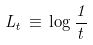Convert formula to latex. <formula><loc_0><loc_0><loc_500><loc_500>L _ { t } \, \equiv \, \log \frac { 1 } { t }</formula> 